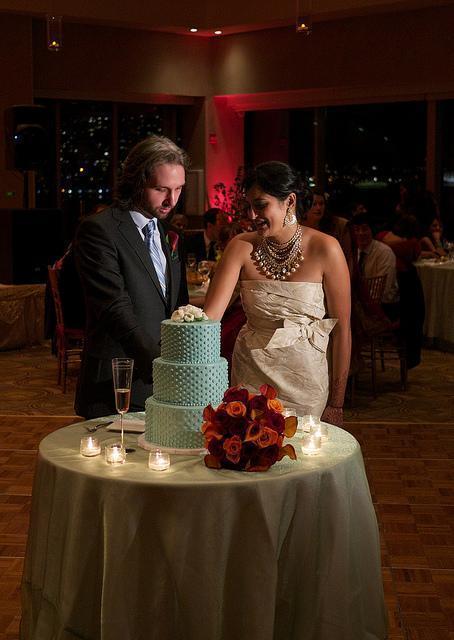How many people can be seen?
Give a very brief answer. 3. How many dining tables can you see?
Give a very brief answer. 1. 